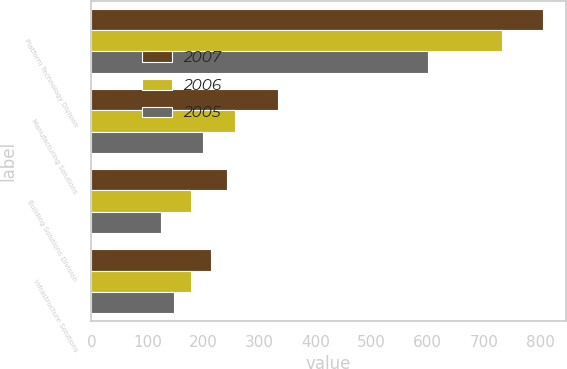Convert chart to OTSL. <chart><loc_0><loc_0><loc_500><loc_500><stacked_bar_chart><ecel><fcel>Platform Technology Division<fcel>Manufacturing Solutions<fcel>Building Solutions Division<fcel>Infrastructure Solutions<nl><fcel>2007<fcel>806.1<fcel>333.1<fcel>241.9<fcel>213.5<nl><fcel>2006<fcel>731.6<fcel>256.9<fcel>177.6<fcel>178.4<nl><fcel>2005<fcel>599.5<fcel>199.7<fcel>124.3<fcel>147.8<nl></chart> 